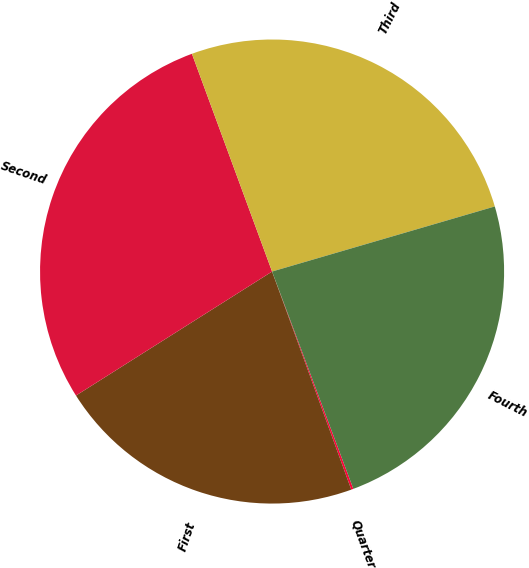Convert chart to OTSL. <chart><loc_0><loc_0><loc_500><loc_500><pie_chart><fcel>Quarter<fcel>First<fcel>Second<fcel>Third<fcel>Fourth<nl><fcel>0.15%<fcel>21.57%<fcel>28.36%<fcel>26.09%<fcel>23.83%<nl></chart> 